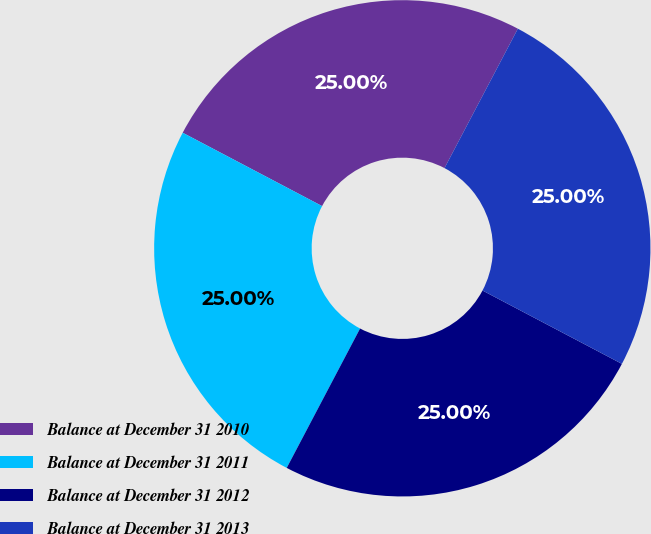<chart> <loc_0><loc_0><loc_500><loc_500><pie_chart><fcel>Balance at December 31 2010<fcel>Balance at December 31 2011<fcel>Balance at December 31 2012<fcel>Balance at December 31 2013<nl><fcel>25.0%<fcel>25.0%<fcel>25.0%<fcel>25.0%<nl></chart> 